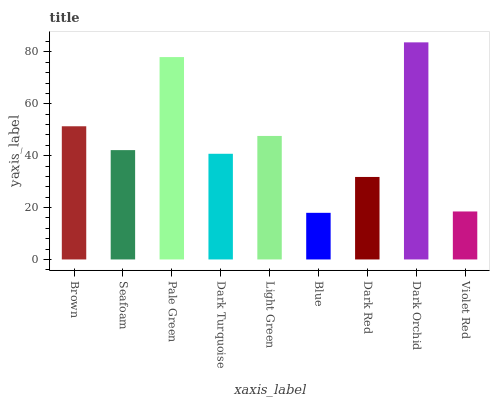Is Seafoam the minimum?
Answer yes or no. No. Is Seafoam the maximum?
Answer yes or no. No. Is Brown greater than Seafoam?
Answer yes or no. Yes. Is Seafoam less than Brown?
Answer yes or no. Yes. Is Seafoam greater than Brown?
Answer yes or no. No. Is Brown less than Seafoam?
Answer yes or no. No. Is Seafoam the high median?
Answer yes or no. Yes. Is Seafoam the low median?
Answer yes or no. Yes. Is Blue the high median?
Answer yes or no. No. Is Dark Red the low median?
Answer yes or no. No. 